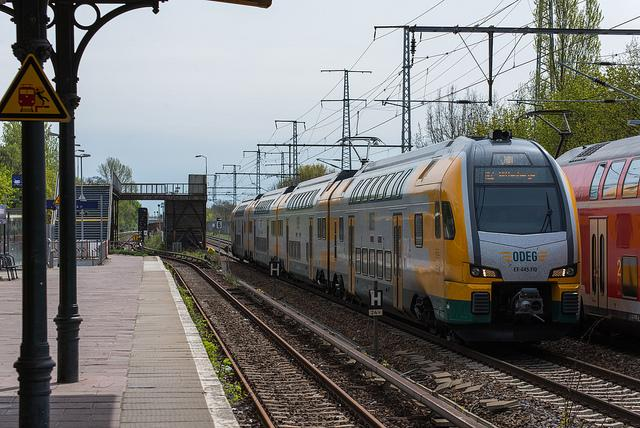What number is on the red train? two 